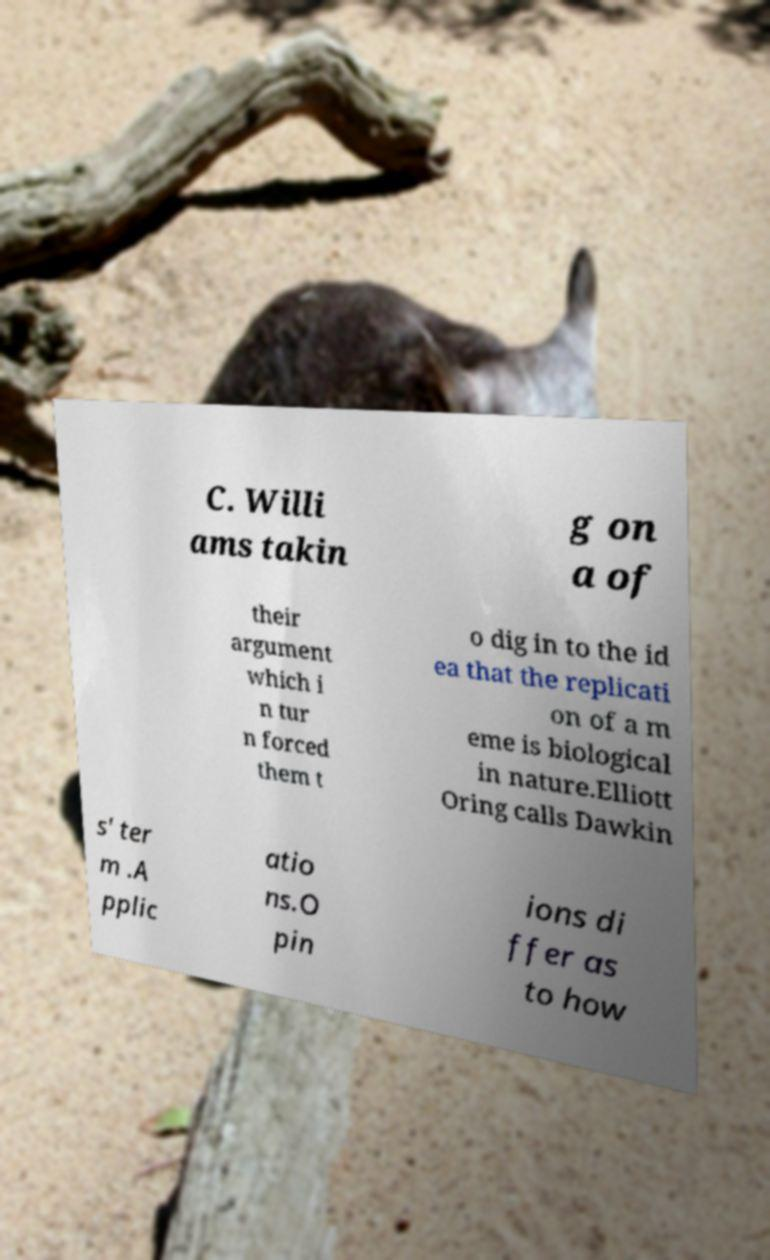I need the written content from this picture converted into text. Can you do that? C. Willi ams takin g on a of their argument which i n tur n forced them t o dig in to the id ea that the replicati on of a m eme is biological in nature.Elliott Oring calls Dawkin s' ter m .A pplic atio ns.O pin ions di ffer as to how 